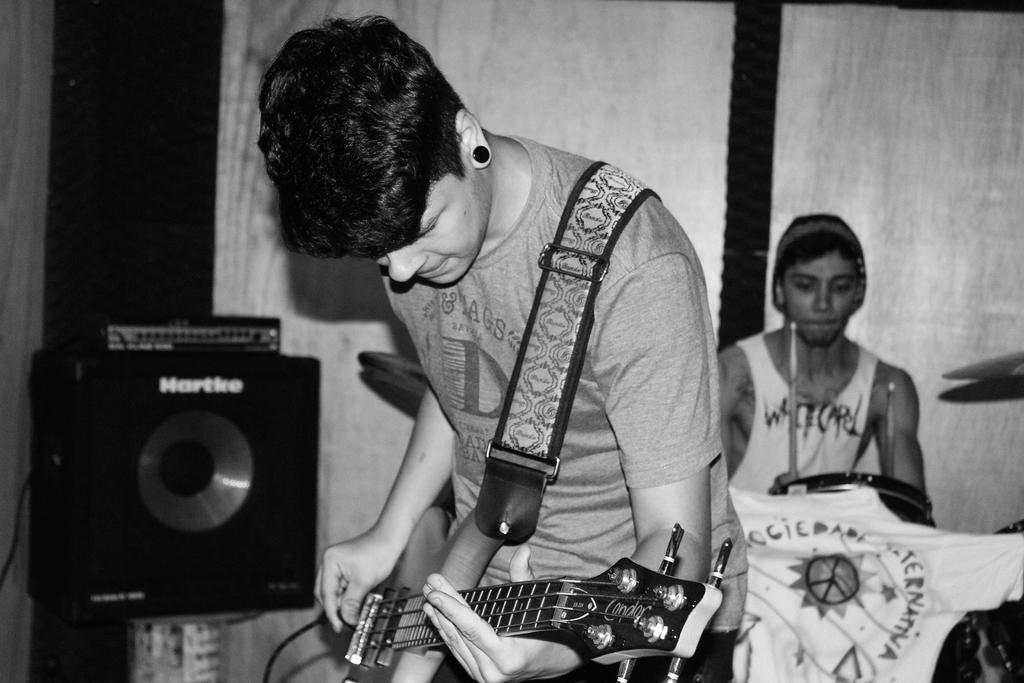How many people are in the image? There are two boys in the image. What are the boys doing in the image? The boys are playing musical instruments. What invention can be seen in the background of the image? There is no invention visible in the image; it only shows two boys playing musical instruments. 